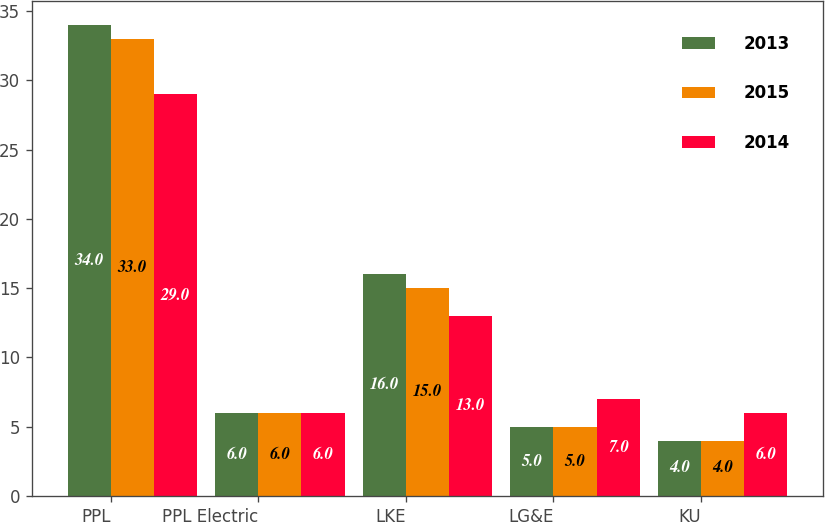<chart> <loc_0><loc_0><loc_500><loc_500><stacked_bar_chart><ecel><fcel>PPL<fcel>PPL Electric<fcel>LKE<fcel>LG&E<fcel>KU<nl><fcel>2013<fcel>34<fcel>6<fcel>16<fcel>5<fcel>4<nl><fcel>2015<fcel>33<fcel>6<fcel>15<fcel>5<fcel>4<nl><fcel>2014<fcel>29<fcel>6<fcel>13<fcel>7<fcel>6<nl></chart> 